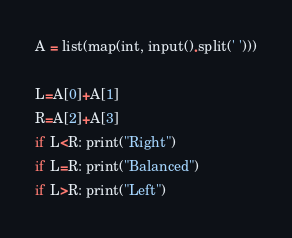Convert code to text. <code><loc_0><loc_0><loc_500><loc_500><_Python_>A = list(map(int, input().split(' ')))

L=A[0]+A[1]
R=A[2]+A[3]
if L<R: print("Right")
if L=R: print("Balanced")
if L>R: print("Left")</code> 